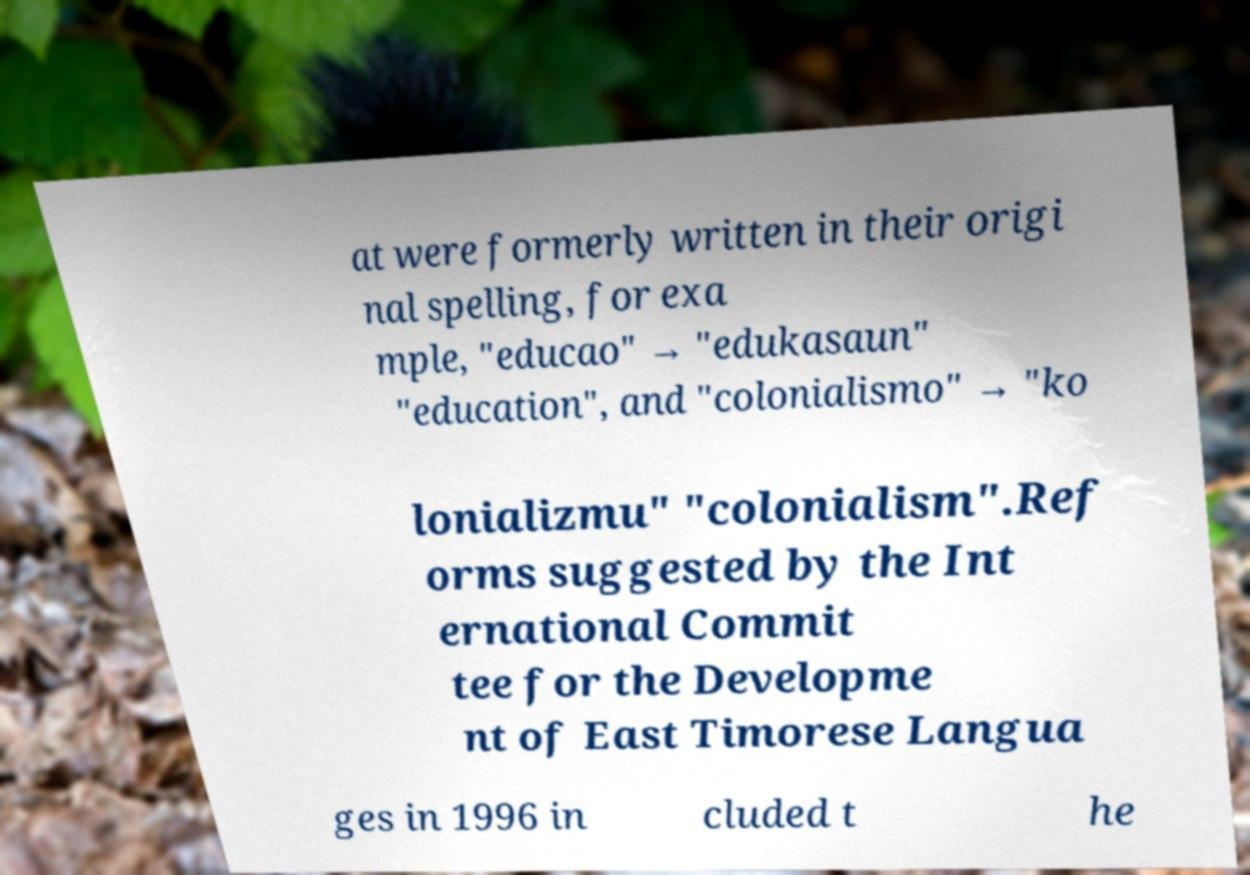Can you read and provide the text displayed in the image?This photo seems to have some interesting text. Can you extract and type it out for me? at were formerly written in their origi nal spelling, for exa mple, "educao" → "edukasaun" "education", and "colonialismo" → "ko lonializmu" "colonialism".Ref orms suggested by the Int ernational Commit tee for the Developme nt of East Timorese Langua ges in 1996 in cluded t he 